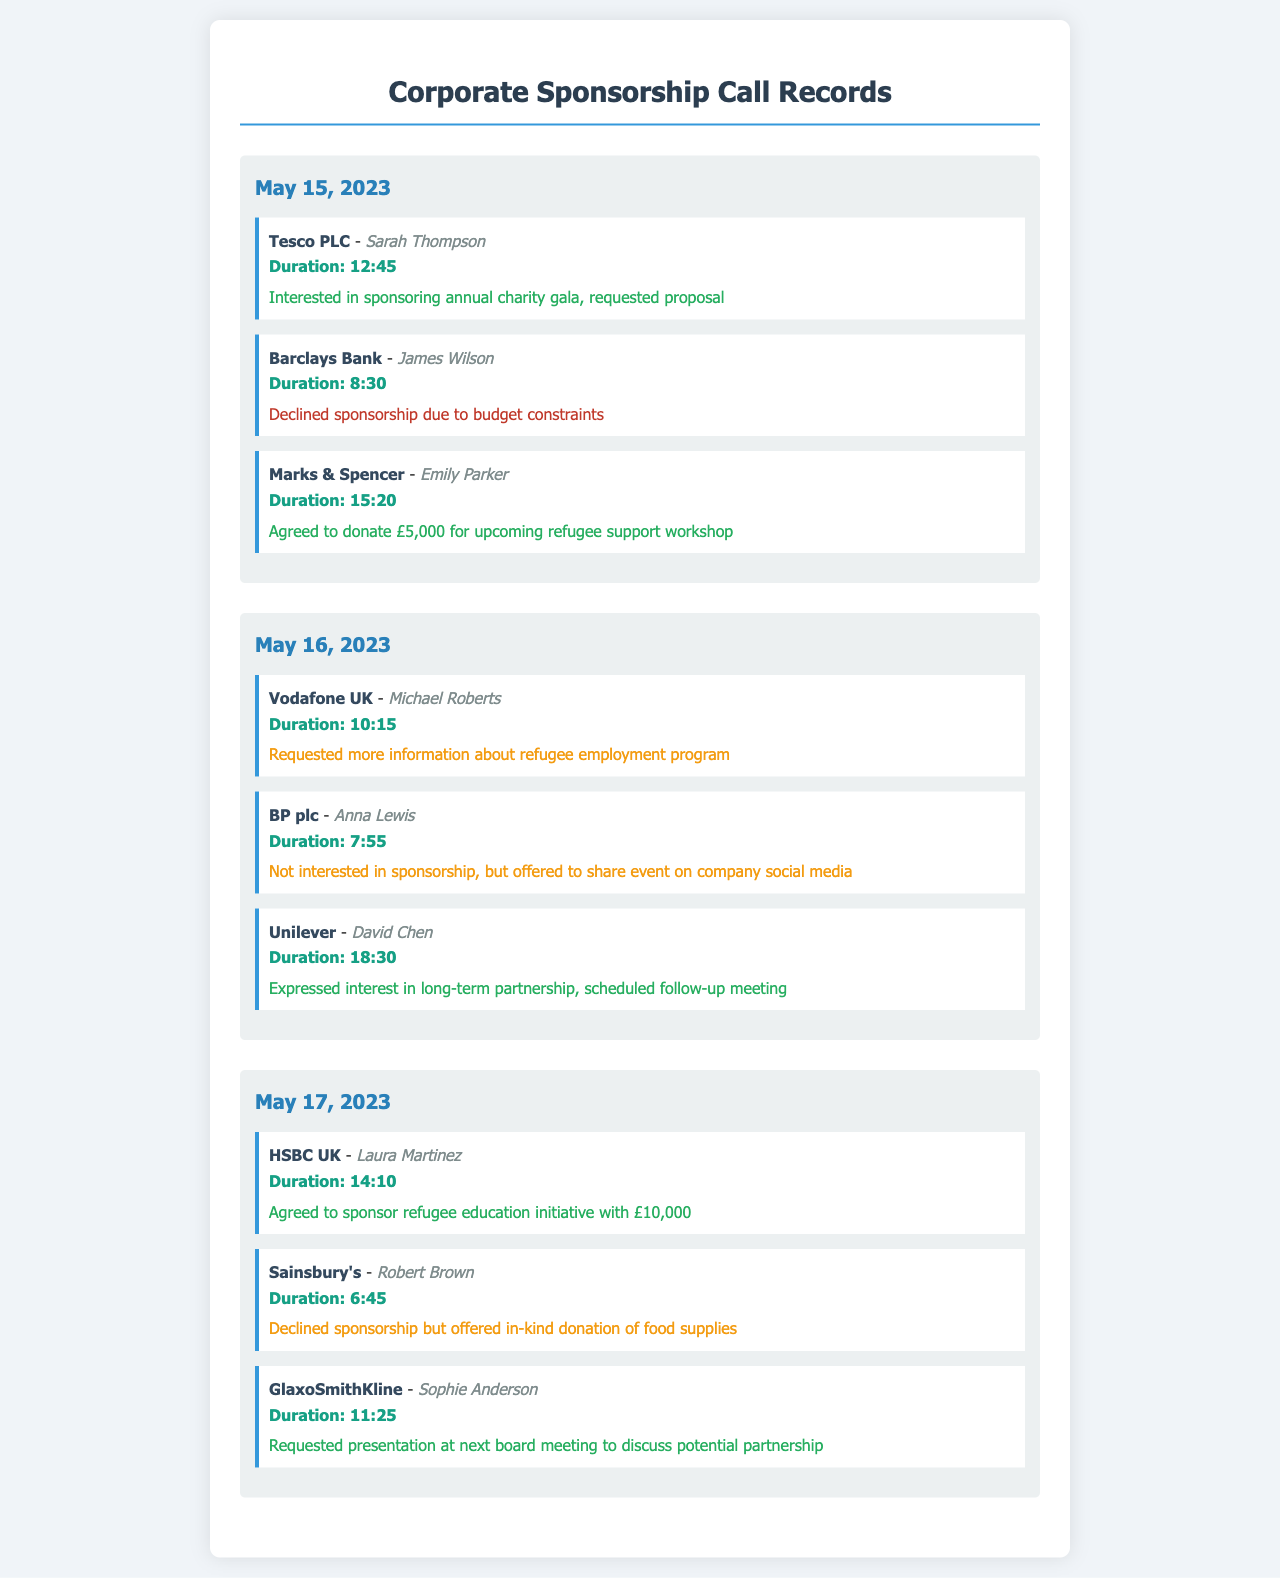what was the call duration with Tesco PLC? The call duration with Tesco PLC is explicitly listed in the record under the duration section.
Answer: 12:45 how much did Marks & Spencer agree to donate? The donation amount from Marks & Spencer is detailed in the outcome section of their call record.
Answer: £5,000 who was the contact person at Barclays Bank? The contact person is mentioned in the call record for Barclays Bank.
Answer: James Wilson how many positive outcomes were recorded on May 16, 2023? The positive outcomes require counting each record with a positive outcome on that date.
Answer: 1 what type of donation did Sainsbury's offer? This is mentioned in the outcome section of Sainsbury's call record and reflects the nature of their offer.
Answer: in-kind donation of food supplies which company expressed interest in a long-term partnership? The company showing interest in a long-term partnership is documented in the call records.
Answer: Unilever which date had the longest call duration with a single company? Evaluating the call durations in the records will indicate which call was the longest on that date.
Answer: May 16, 2023 what was the outcome of the call with HSBC UK? This outcome is directly stated in the call record for HSBC UK under the outcome section.
Answer: Agreed to sponsor refugee education initiative with £10,000 what was the total number of calls made on May 17, 2023? The total number of calls is determined by counting the entries listed for that particular date in the records.
Answer: 3 